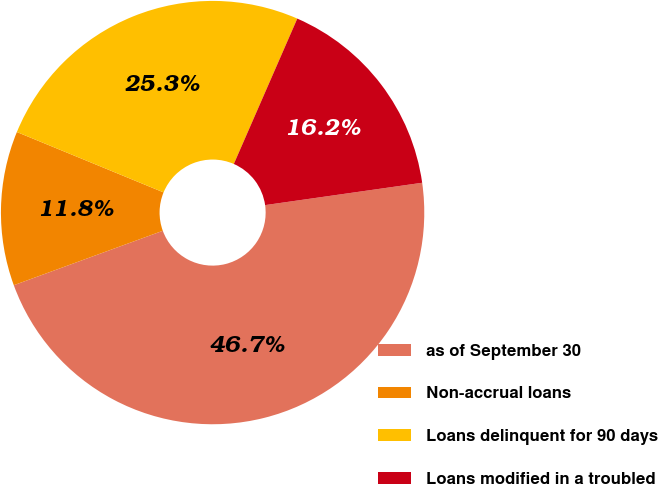Convert chart to OTSL. <chart><loc_0><loc_0><loc_500><loc_500><pie_chart><fcel>as of September 30<fcel>Non-accrual loans<fcel>Loans delinquent for 90 days<fcel>Loans modified in a troubled<nl><fcel>46.68%<fcel>11.79%<fcel>25.34%<fcel>16.2%<nl></chart> 